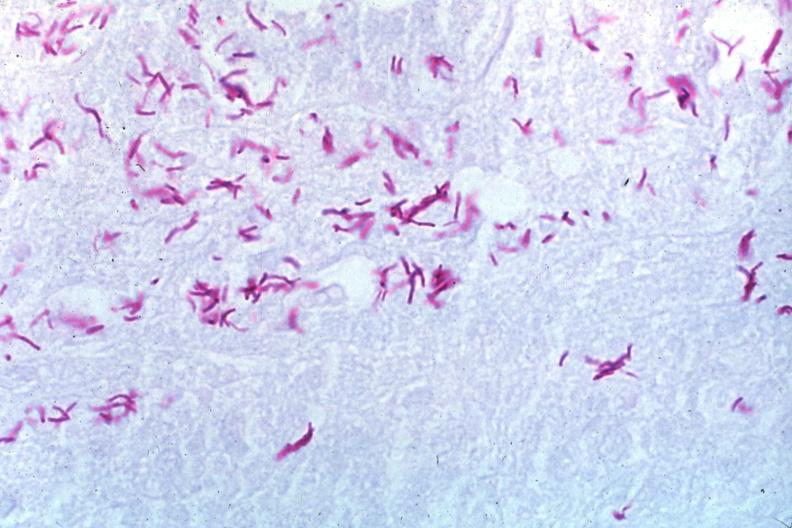does this image show oil acid fast stain a zillion organisms?
Answer the question using a single word or phrase. Yes 